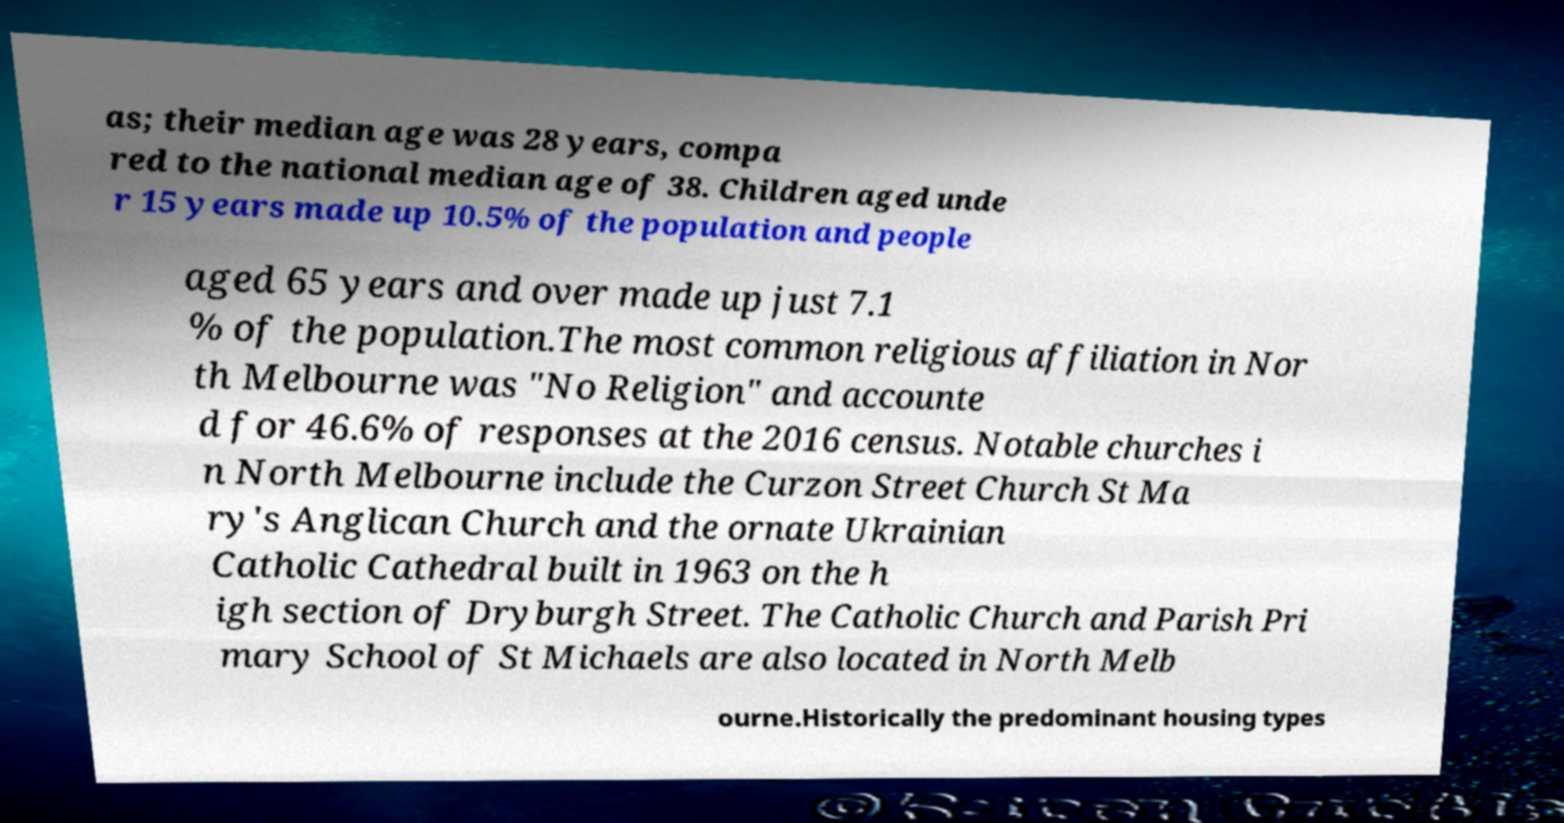Can you accurately transcribe the text from the provided image for me? as; their median age was 28 years, compa red to the national median age of 38. Children aged unde r 15 years made up 10.5% of the population and people aged 65 years and over made up just 7.1 % of the population.The most common religious affiliation in Nor th Melbourne was "No Religion" and accounte d for 46.6% of responses at the 2016 census. Notable churches i n North Melbourne include the Curzon Street Church St Ma ry's Anglican Church and the ornate Ukrainian Catholic Cathedral built in 1963 on the h igh section of Dryburgh Street. The Catholic Church and Parish Pri mary School of St Michaels are also located in North Melb ourne.Historically the predominant housing types 